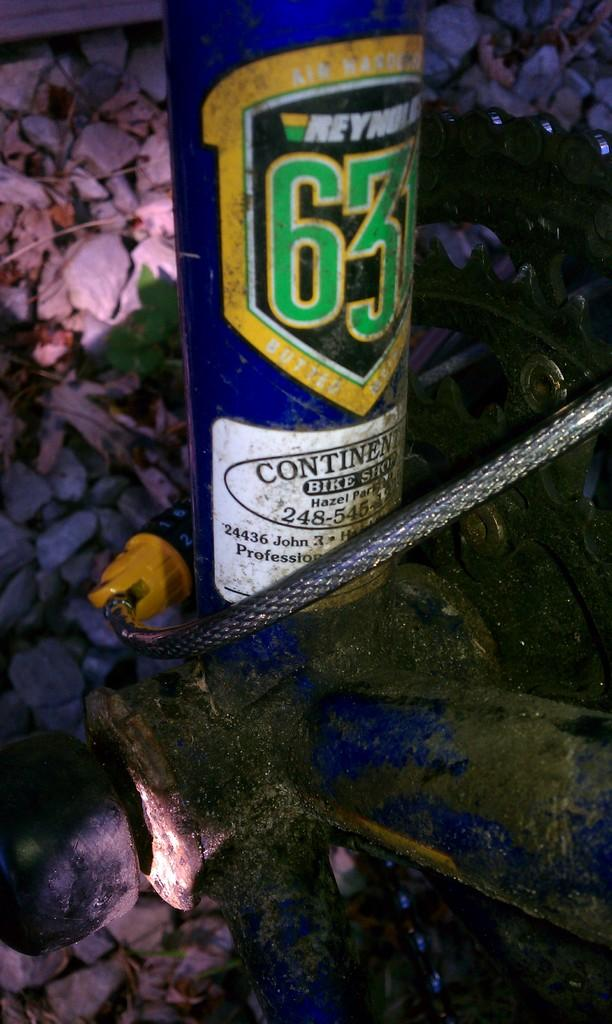<image>
Provide a brief description of the given image. A blue canister that was purchased at Continental Bike Shop. 